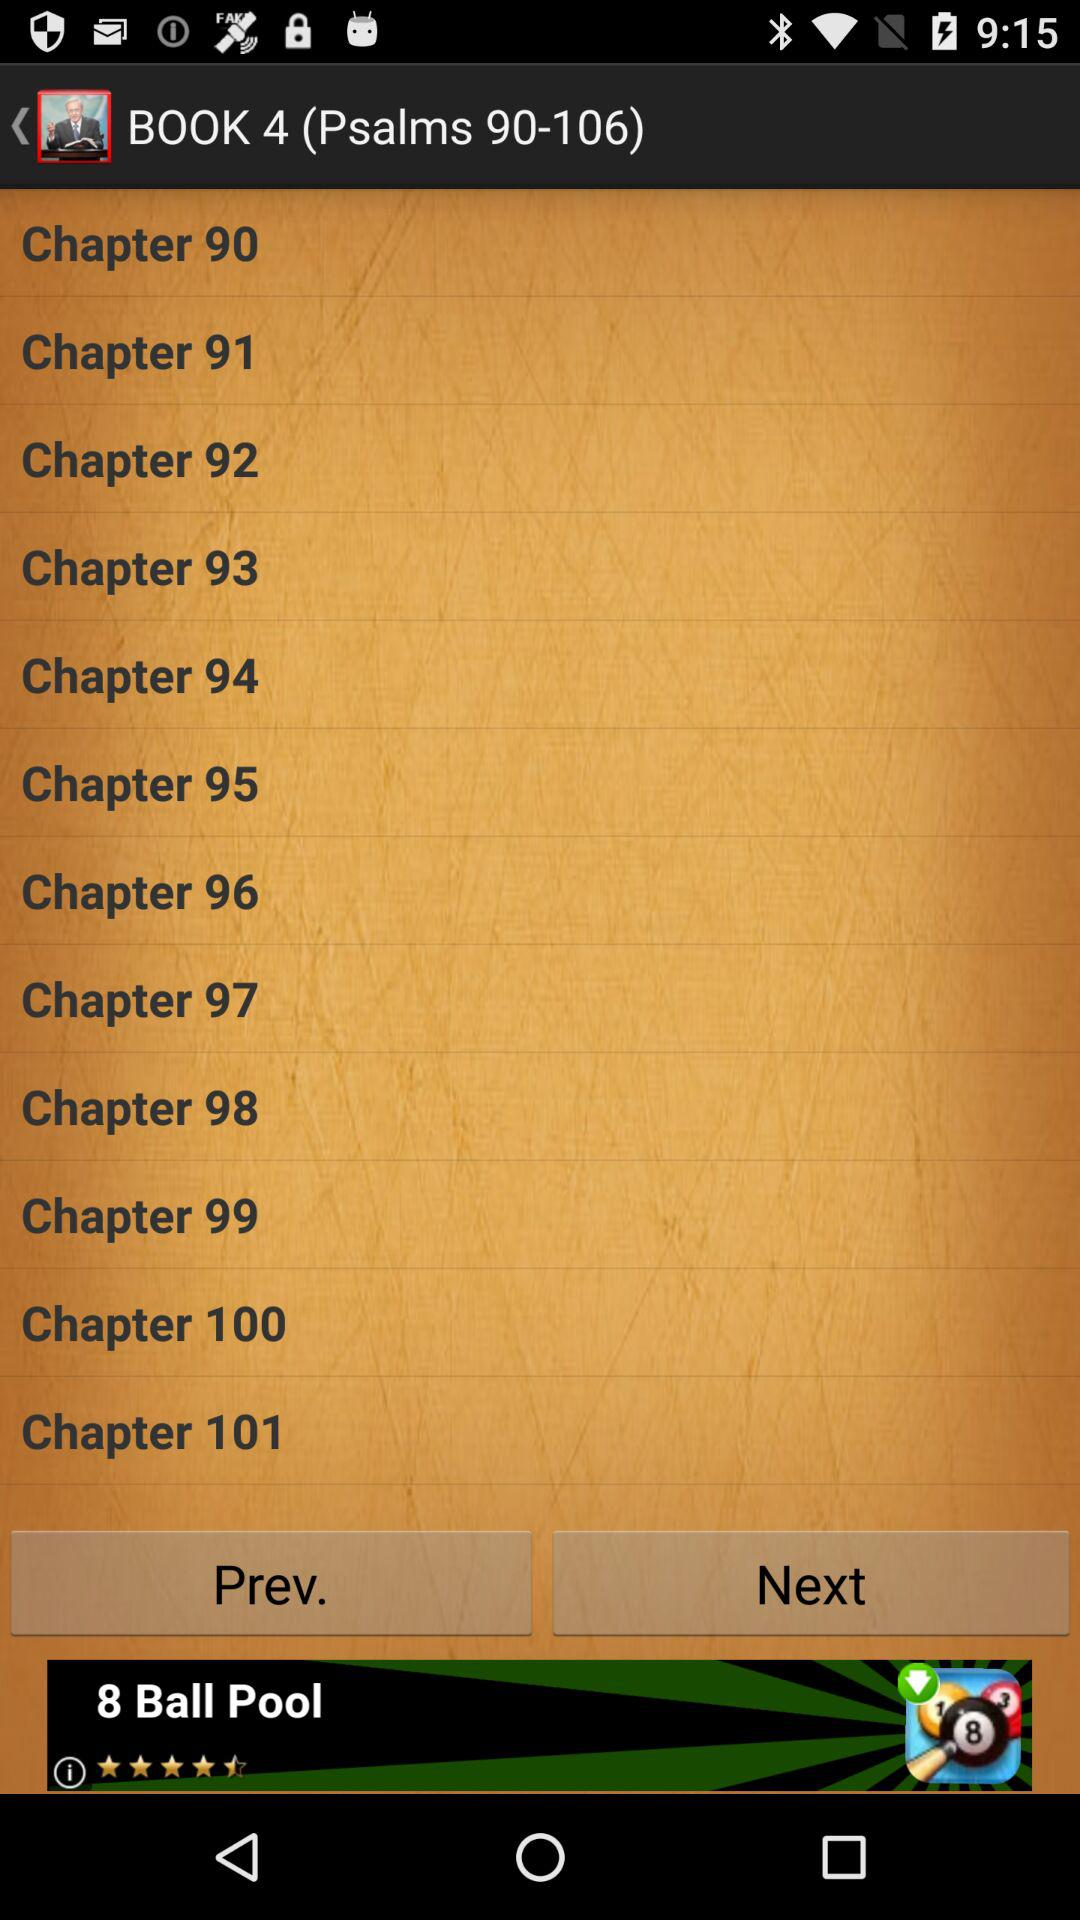Which book contains "Psalms 90-106"? "Psalms 90-106" is present in "BOOK 4". 